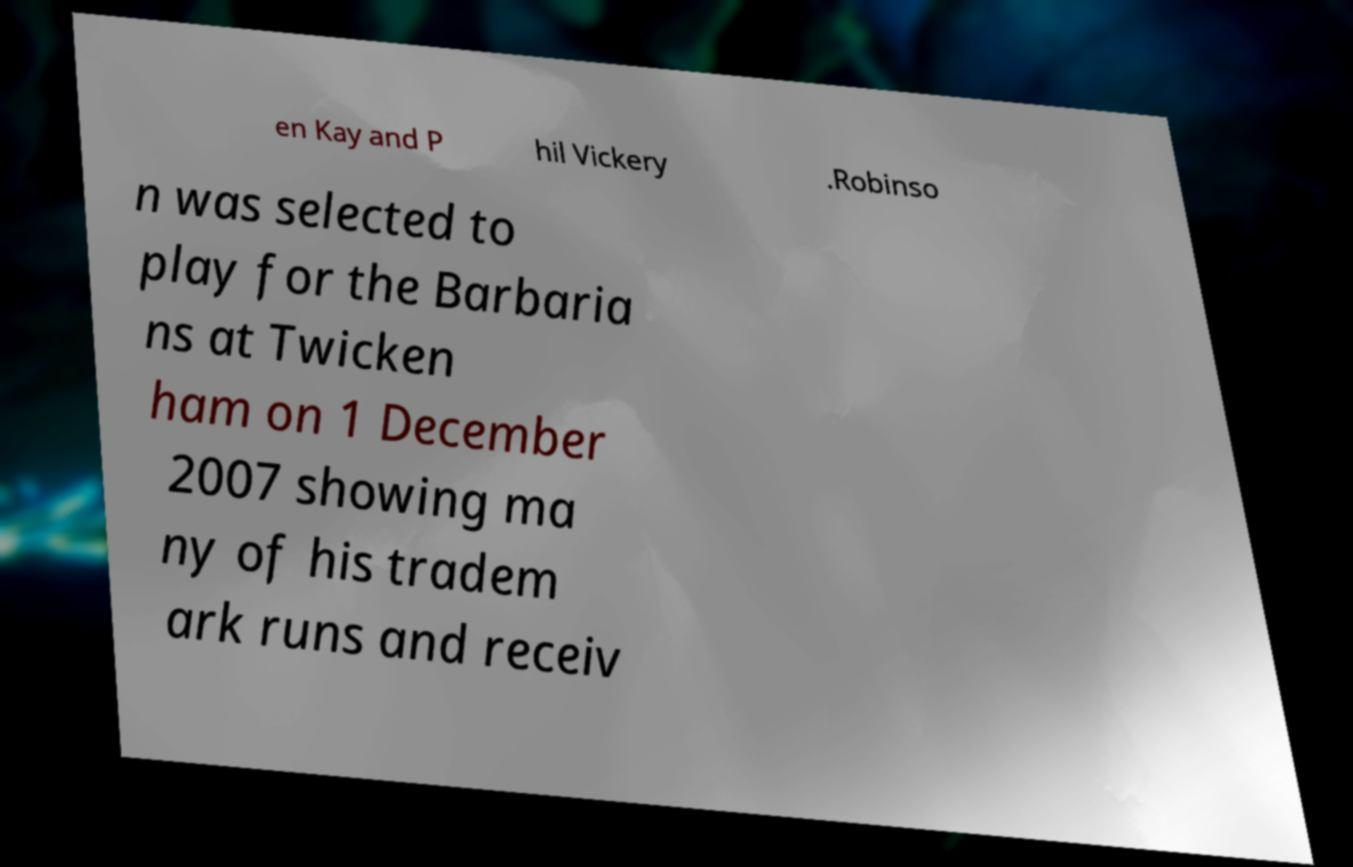I need the written content from this picture converted into text. Can you do that? en Kay and P hil Vickery .Robinso n was selected to play for the Barbaria ns at Twicken ham on 1 December 2007 showing ma ny of his tradem ark runs and receiv 